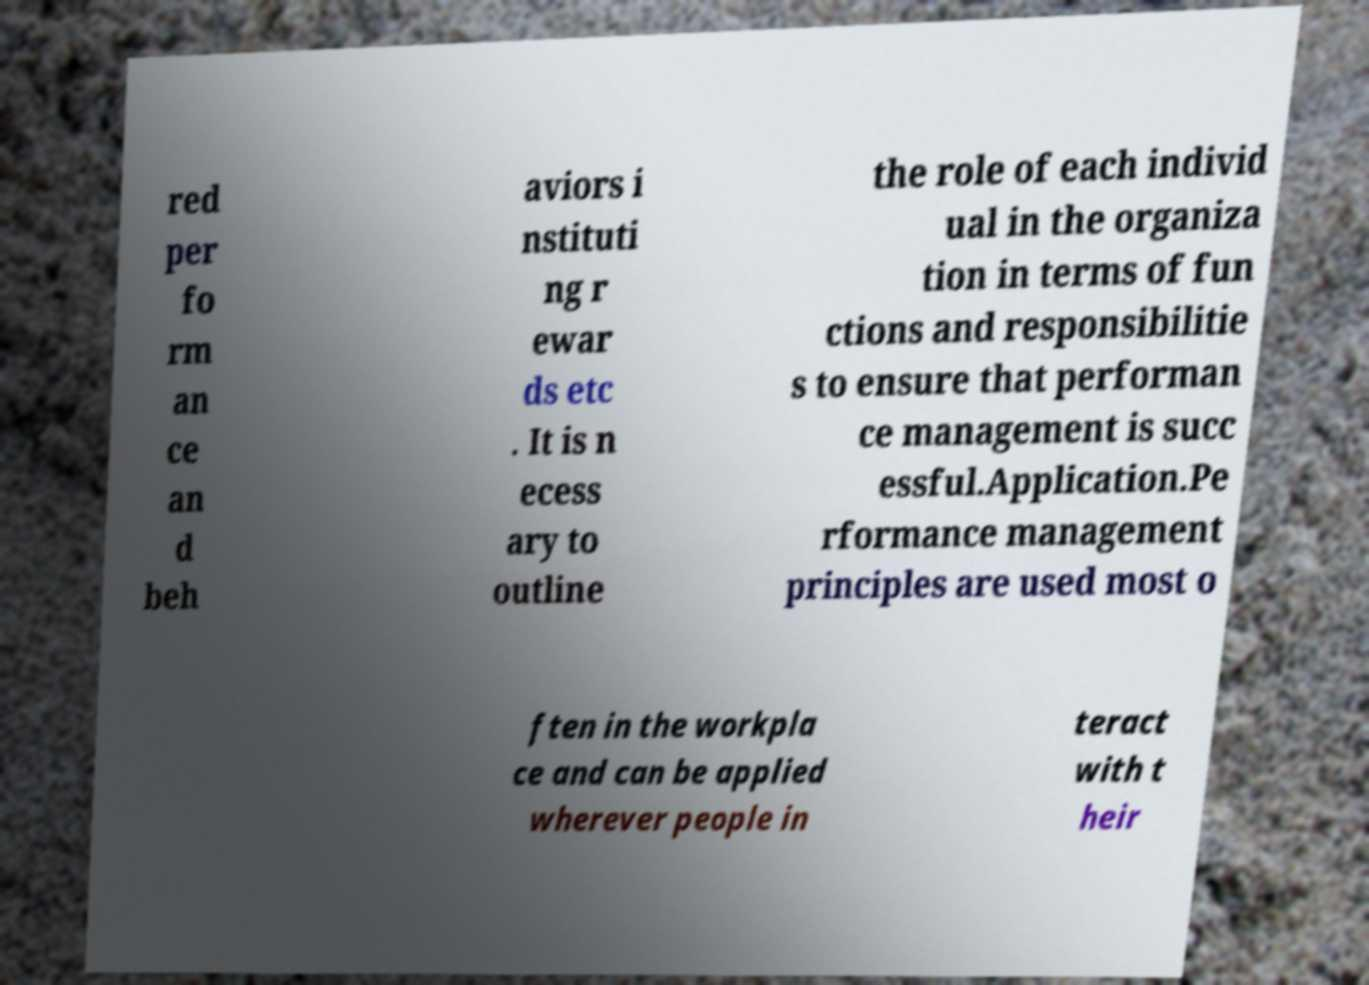Could you extract and type out the text from this image? red per fo rm an ce an d beh aviors i nstituti ng r ewar ds etc . It is n ecess ary to outline the role of each individ ual in the organiza tion in terms of fun ctions and responsibilitie s to ensure that performan ce management is succ essful.Application.Pe rformance management principles are used most o ften in the workpla ce and can be applied wherever people in teract with t heir 